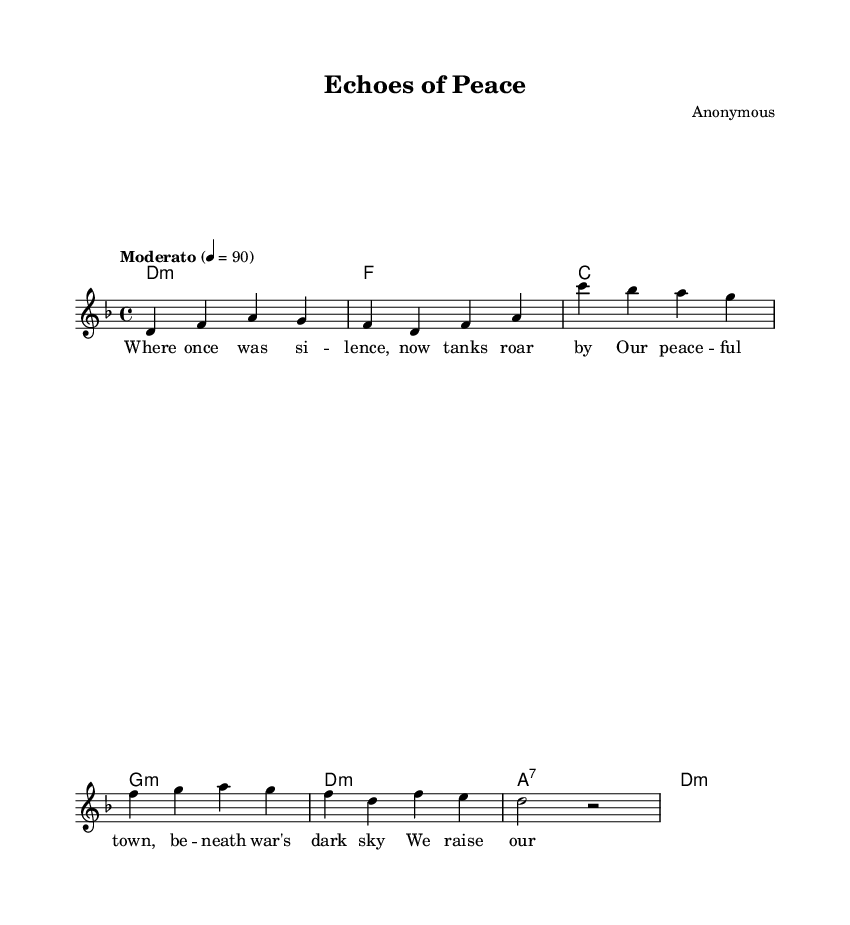What is the key signature of this music? The key signature is D minor, which has one flat (B flat). This can be determined by looking at the key signature indicated at the beginning of the music.
Answer: D minor What is the time signature of this music? The time signature is 4/4, which means there are four beats in each measure. This is indicated at the start of the sheet music.
Answer: 4/4 What is the tempo marking for this piece? The tempo marking is Moderato, which means a moderate speed, indicated in the tempo directive in the music.
Answer: Moderato How many measures are in the piece? There are 8 measures in the music. Each measure is counted from the beginning of the staff to the end of the voice part, and there are 8 groups of beats counted.
Answer: 8 What is the title of this music? The title of the music is "Echoes of Peace," which is clearly indicated in the header section of the sheet music.
Answer: Echoes of Peace What is the lyrical theme of the piece? The theme is anti-war, as indicated by the lyrics which reflect protest against war and longing for peace. To ascertain this, one can read the lyric content which clearly expresses these sentiments.
Answer: Anti-war What chord is used at the end of the piece? The last chord used at the end of the piece is D minor, which can be determined by the final chord notated in the chord mode section of the music.
Answer: D minor 